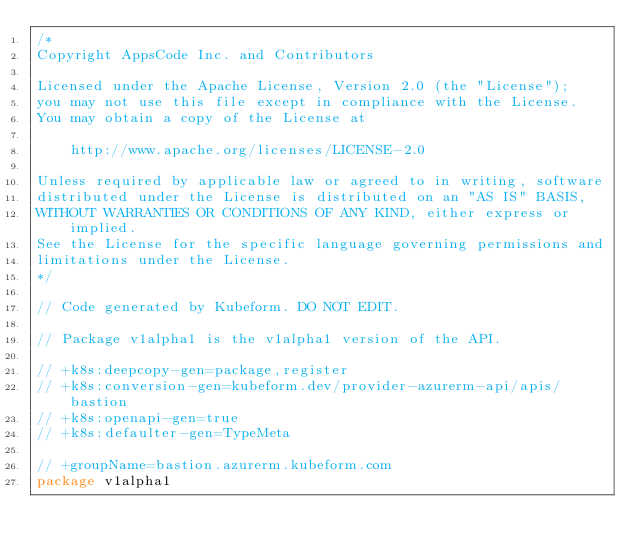<code> <loc_0><loc_0><loc_500><loc_500><_Go_>/*
Copyright AppsCode Inc. and Contributors

Licensed under the Apache License, Version 2.0 (the "License");
you may not use this file except in compliance with the License.
You may obtain a copy of the License at

    http://www.apache.org/licenses/LICENSE-2.0

Unless required by applicable law or agreed to in writing, software
distributed under the License is distributed on an "AS IS" BASIS,
WITHOUT WARRANTIES OR CONDITIONS OF ANY KIND, either express or implied.
See the License for the specific language governing permissions and
limitations under the License.
*/

// Code generated by Kubeform. DO NOT EDIT.

// Package v1alpha1 is the v1alpha1 version of the API.

// +k8s:deepcopy-gen=package,register
// +k8s:conversion-gen=kubeform.dev/provider-azurerm-api/apis/bastion
// +k8s:openapi-gen=true
// +k8s:defaulter-gen=TypeMeta

// +groupName=bastion.azurerm.kubeform.com
package v1alpha1
</code> 